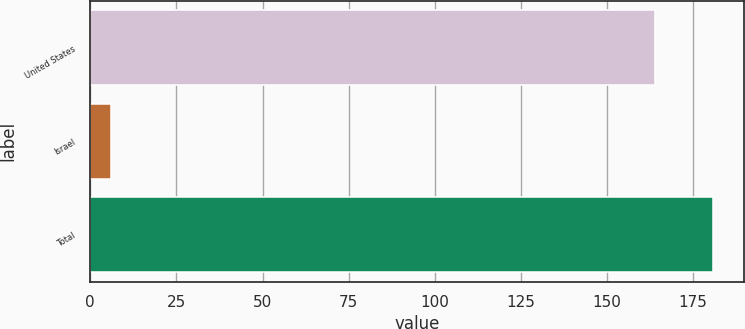<chart> <loc_0><loc_0><loc_500><loc_500><bar_chart><fcel>United States<fcel>Israel<fcel>Total<nl><fcel>164<fcel>6<fcel>180.8<nl></chart> 